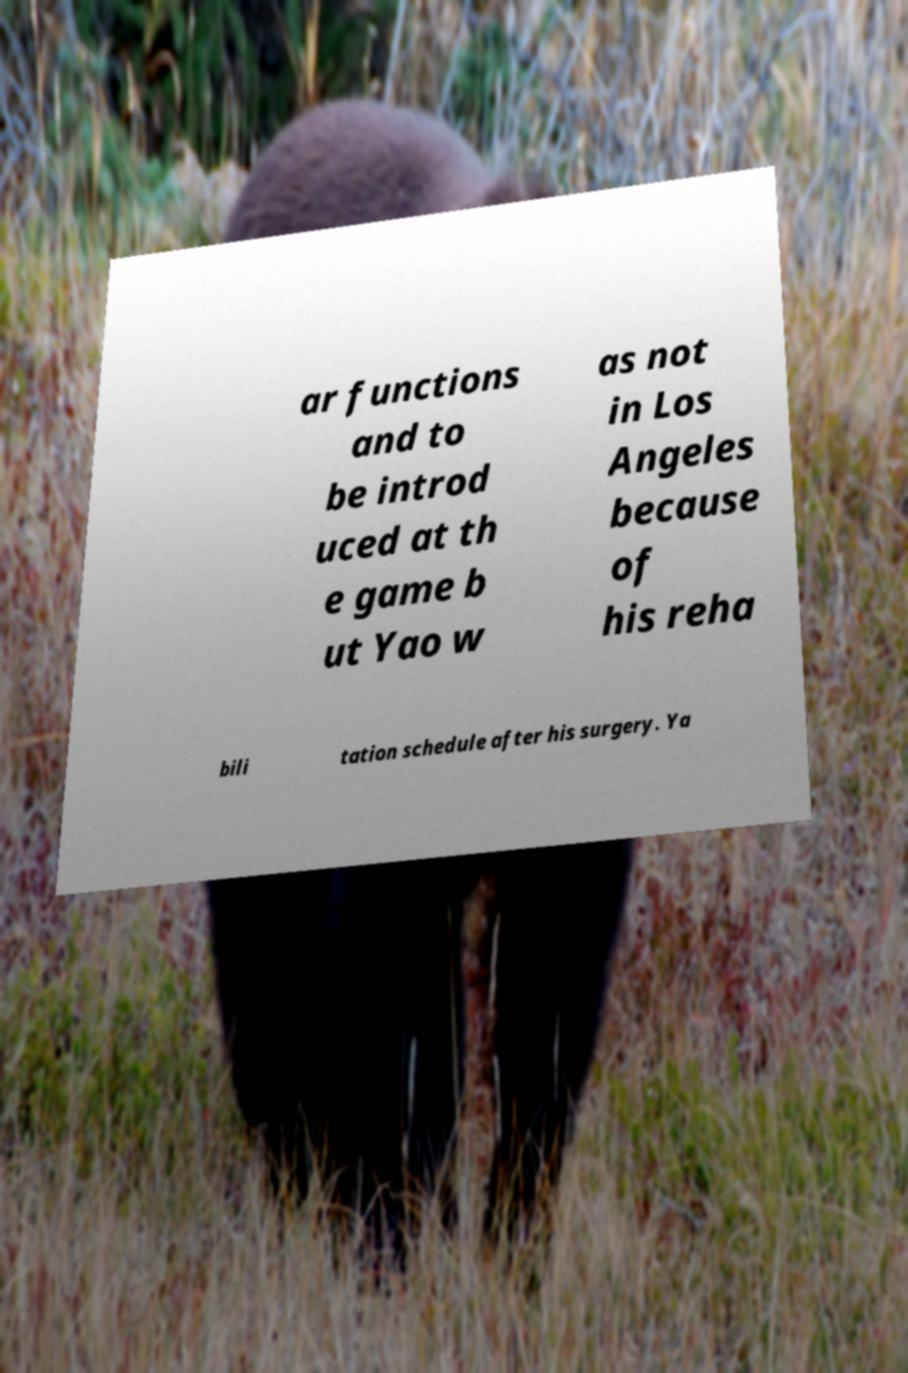What messages or text are displayed in this image? I need them in a readable, typed format. ar functions and to be introd uced at th e game b ut Yao w as not in Los Angeles because of his reha bili tation schedule after his surgery. Ya 